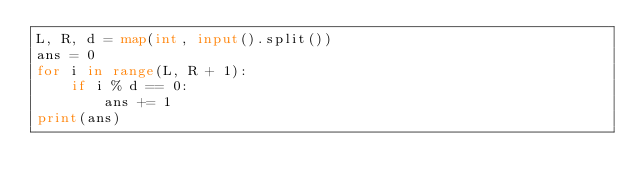<code> <loc_0><loc_0><loc_500><loc_500><_Python_>L, R, d = map(int, input().split())
ans = 0
for i in range(L, R + 1):
    if i % d == 0:
        ans += 1
print(ans)</code> 